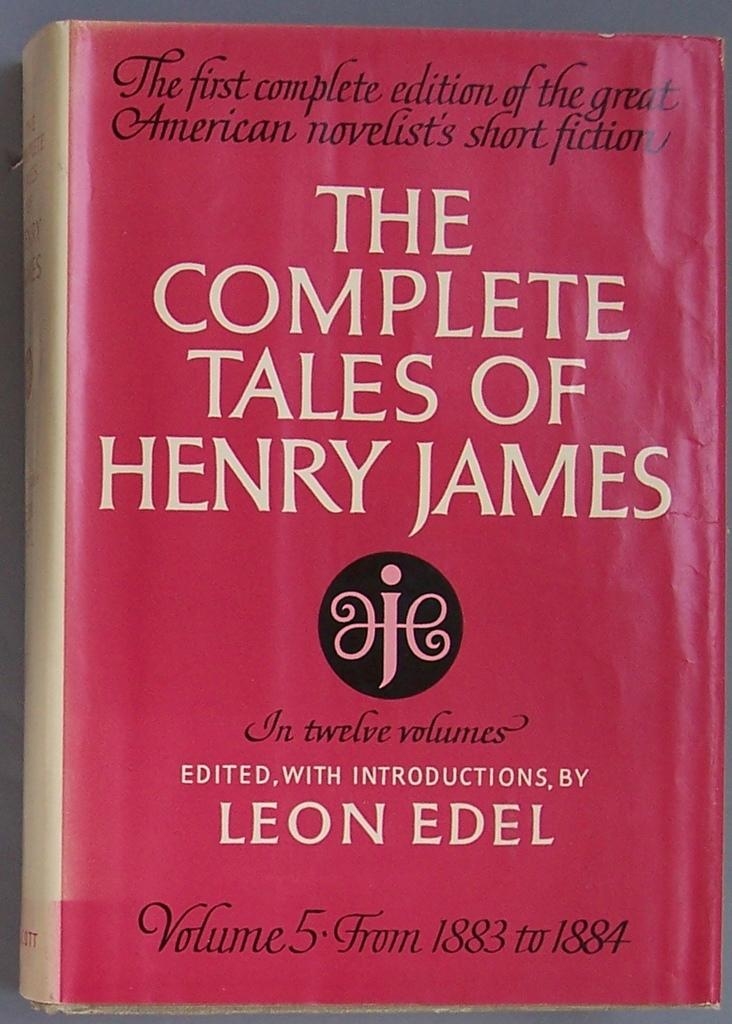<image>
Render a clear and concise summary of the photo. Red book called The Complete Tales of Henry James. 